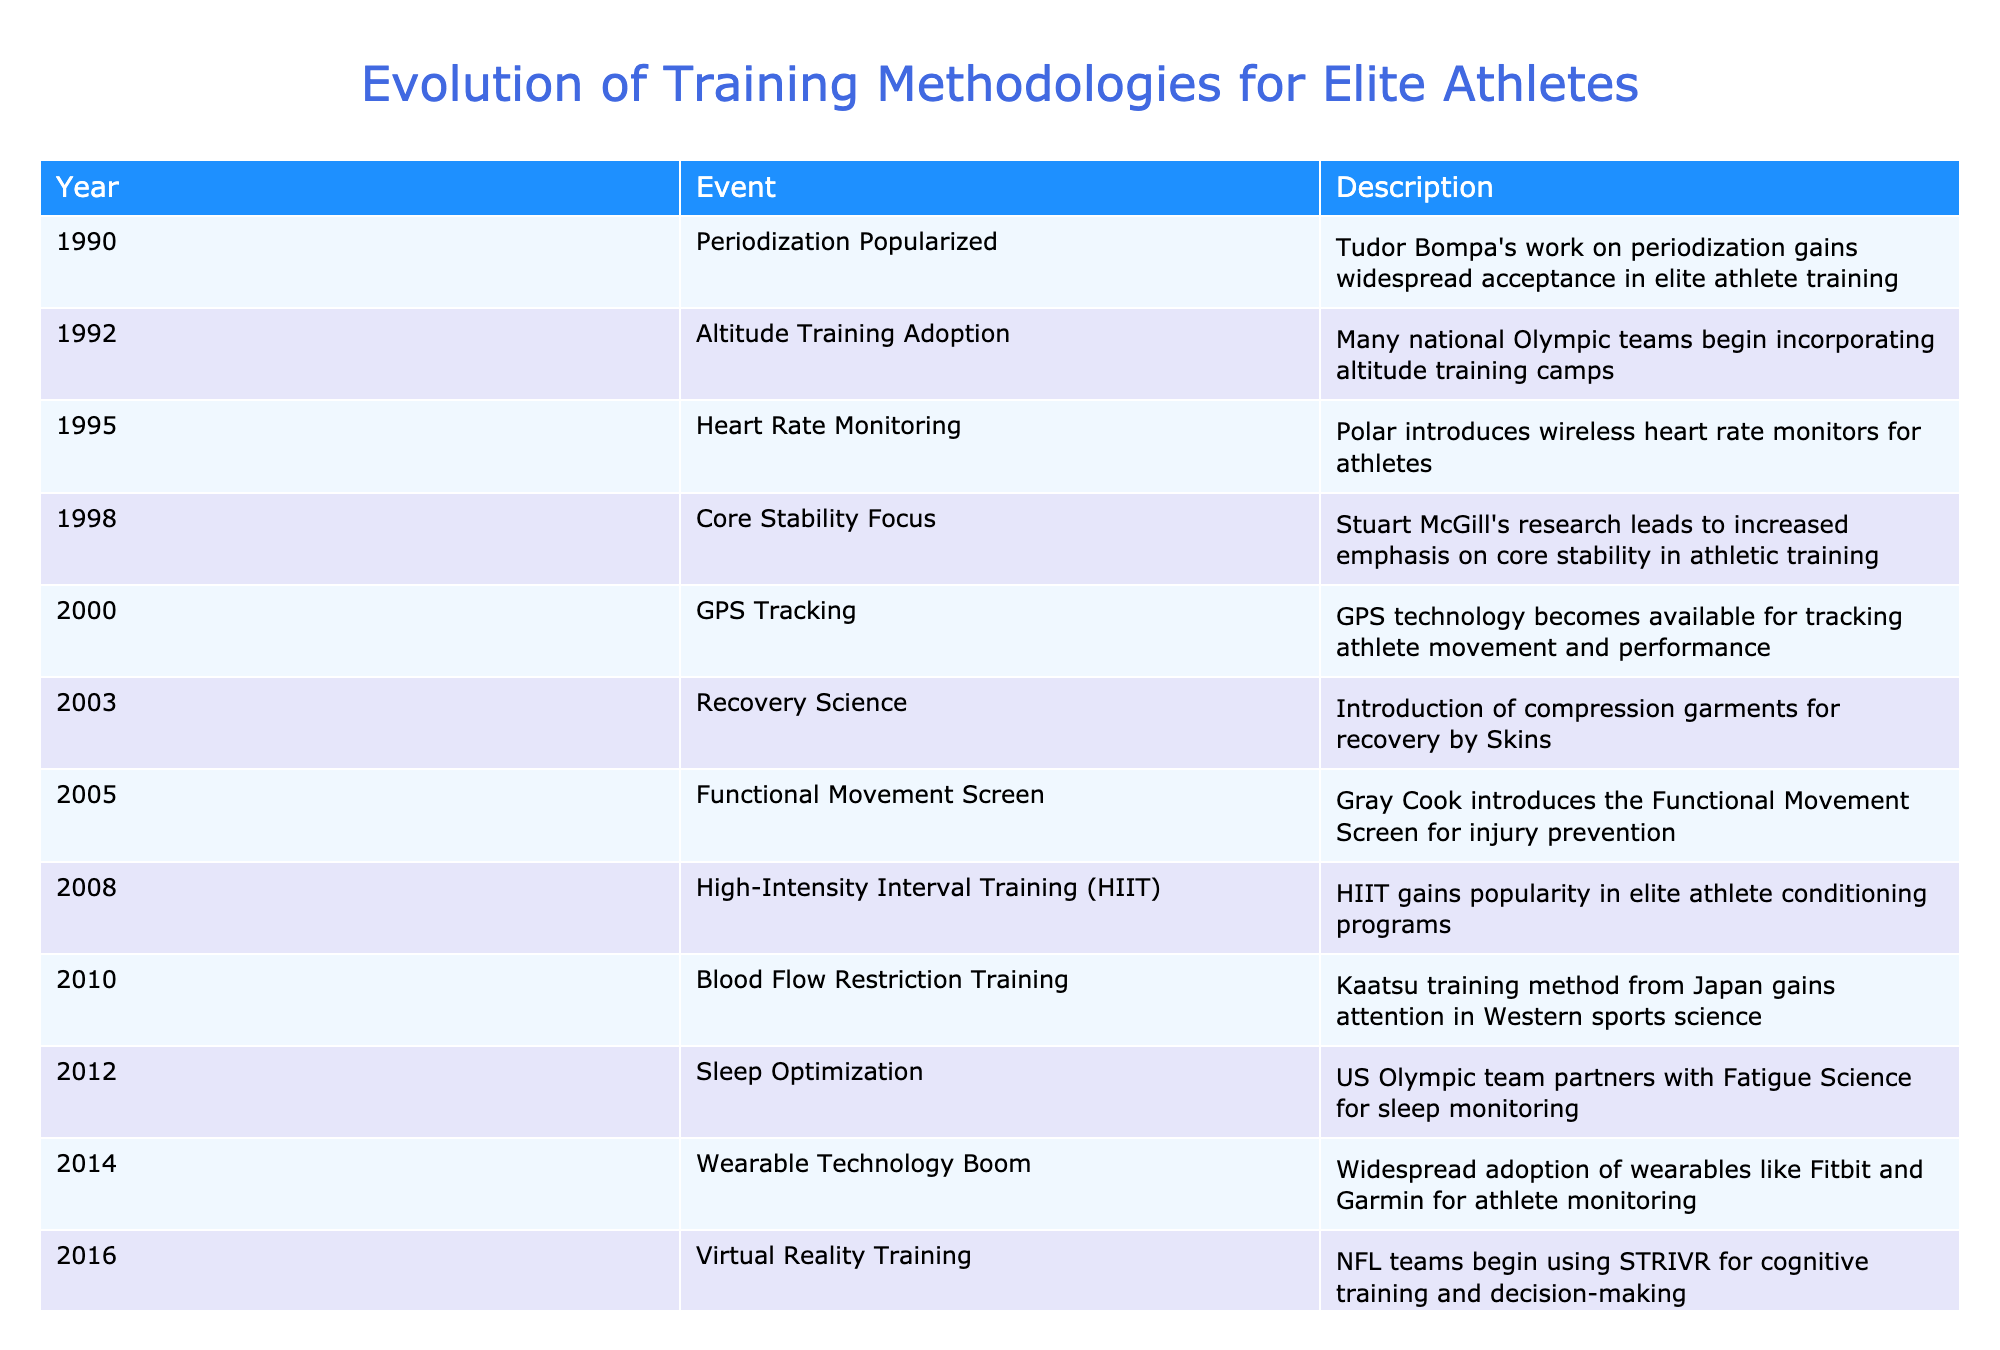What year was Blood Flow Restriction Training introduced? The table lists the event "Blood Flow Restriction Training" with the corresponding year being 2010.
Answer: 2010 Which training methodology was popularized in 1990? According to the table, the event "Periodization Popularized" is listed for the year 1990, indicating that this methodology gained acceptance in elite athlete training during that year.
Answer: Periodization What are the years in which Altitude Training and Core Stability Focus events occurred? The table shows that "Altitude Training Adoption" occurred in 1992 and "Core Stability Focus" happened in 1998. Therefore, the years are 1992 and 1998.
Answer: 1992 and 1998 How many years apart were the introductions of GPS Tracking and Recovery Science methods? GPS Tracking was introduced in 2000 and Recovery Science was introduced in 2003. The difference between these years is 3 years (2003 - 2000 = 3).
Answer: 3 years Was Wearable Technology more commonly adopted before or after 2014? The table states that "Wearable Technology Boom" occurred in 2014, meaning it became common in that year. Therefore, any event concerning wearable technology would have been prior to this year before adoption. Thus, the answer is after.
Answer: After What is the trend observed in training methodologies based on the events listed from 1990 to 2022? The table shows a progression of training methodologies over the years, from periodization and altitude training techniques in the early 1990s to advanced technologies like AI and neurofeedback in the 2020s, indicating a trend towards greater integration of technology and scientific research in athletic training strategies.
Answer: Increasing integration of technology Which two years had significant advancements or methodologies related to recovery techniques? The table lists "Recovery Science" in 2003 and "Sleep Optimization" in 2012 as events related to recovery techniques, indicating significant advancements in these years. Therefore, the answer is 2003 and 2012.
Answer: 2003 and 2012 What year marks the introduction of Genetic Testing, and how does it relate to earlier methodologies? The introduction of Genetic Testing occurred in 2018, reflecting a shift towards personalized approaches in athletic training that builds upon earlier methodologies focused on general training adjustments prevalent since 1990. Hence, it scored a new height by combining genetics with training practices.
Answer: 2018 How many events mentioned in the table occurred in the 2000s? Between the years 2000 and 2009, there are five events listed: GPS Tracking (2000), Recovery Science (2003), Functional Movement Screen (2005), HIIT (2008), and Blood Flow Restriction Training (2010). Thus, there are five events specifically between 2000 and 2009.
Answer: 5 events 